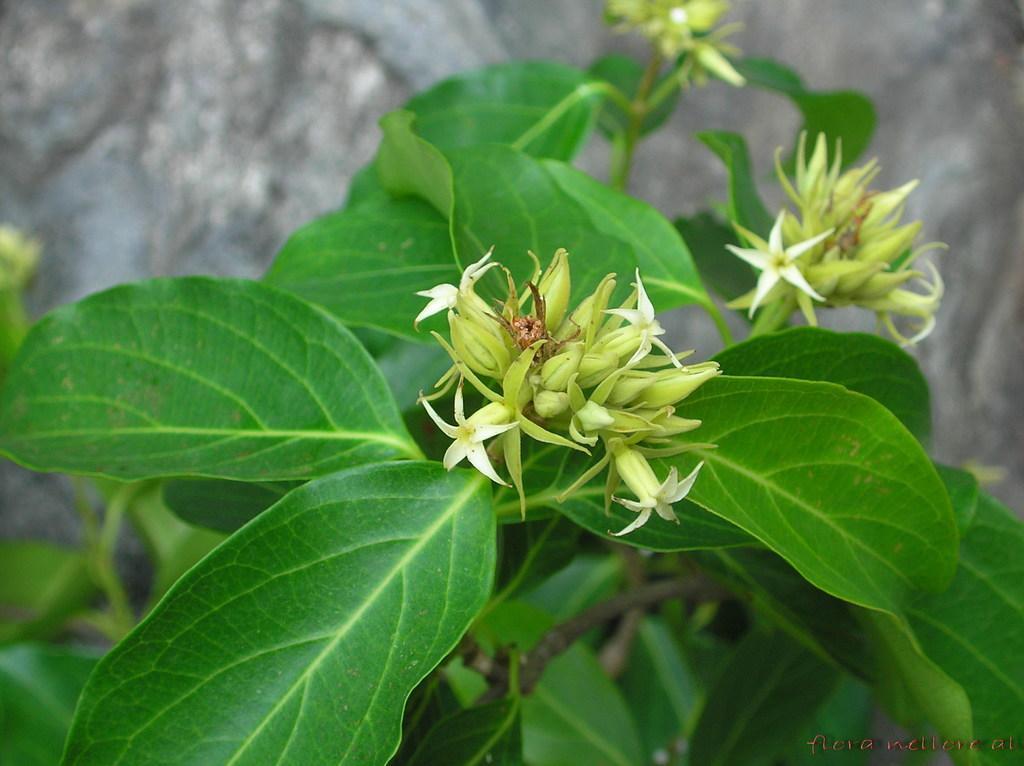In one or two sentences, can you explain what this image depicts? In this picture we can see a plant with green leaves and white flowers. 